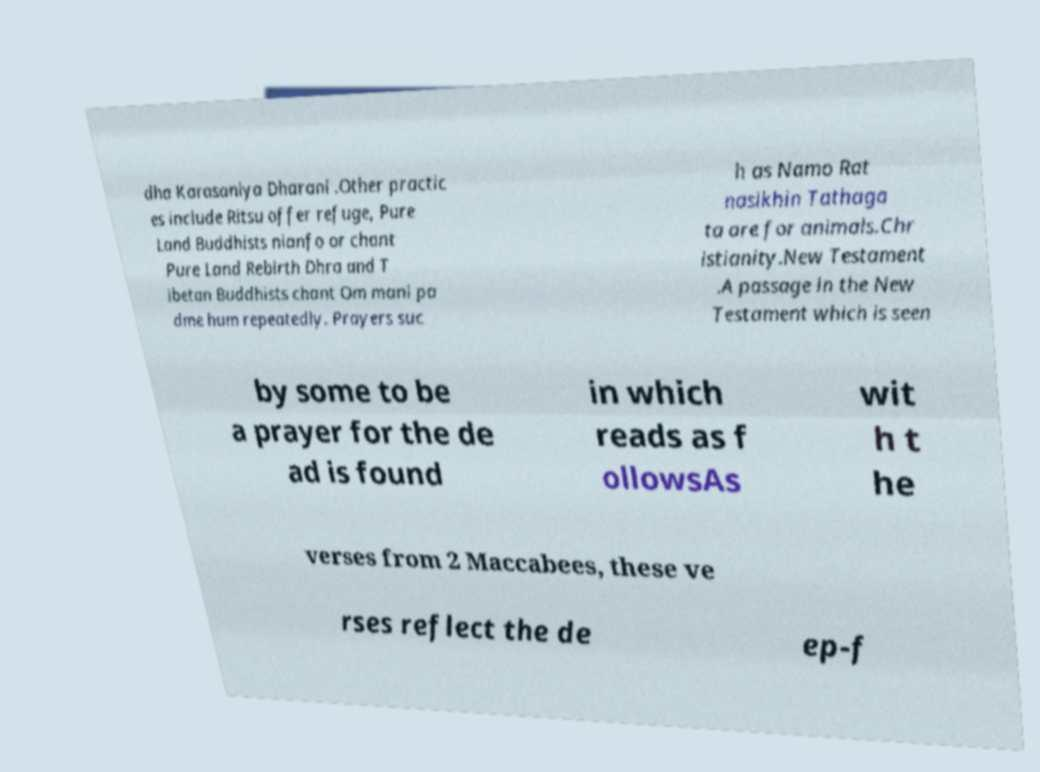Could you extract and type out the text from this image? dha Karasaniya Dharani .Other practic es include Ritsu offer refuge, Pure Land Buddhists nianfo or chant Pure Land Rebirth Dhra and T ibetan Buddhists chant Om mani pa dme hum repeatedly. Prayers suc h as Namo Rat nasikhin Tathaga ta are for animals.Chr istianity.New Testament .A passage in the New Testament which is seen by some to be a prayer for the de ad is found in which reads as f ollowsAs wit h t he verses from 2 Maccabees, these ve rses reflect the de ep-f 